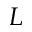<formula> <loc_0><loc_0><loc_500><loc_500>L</formula> 